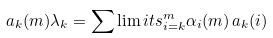Convert formula to latex. <formula><loc_0><loc_0><loc_500><loc_500>a _ { k } ( m ) \lambda _ { k } = \sum \lim i t s _ { i = k } ^ { m } \alpha _ { i } ( m ) \, a _ { k } ( i )</formula> 